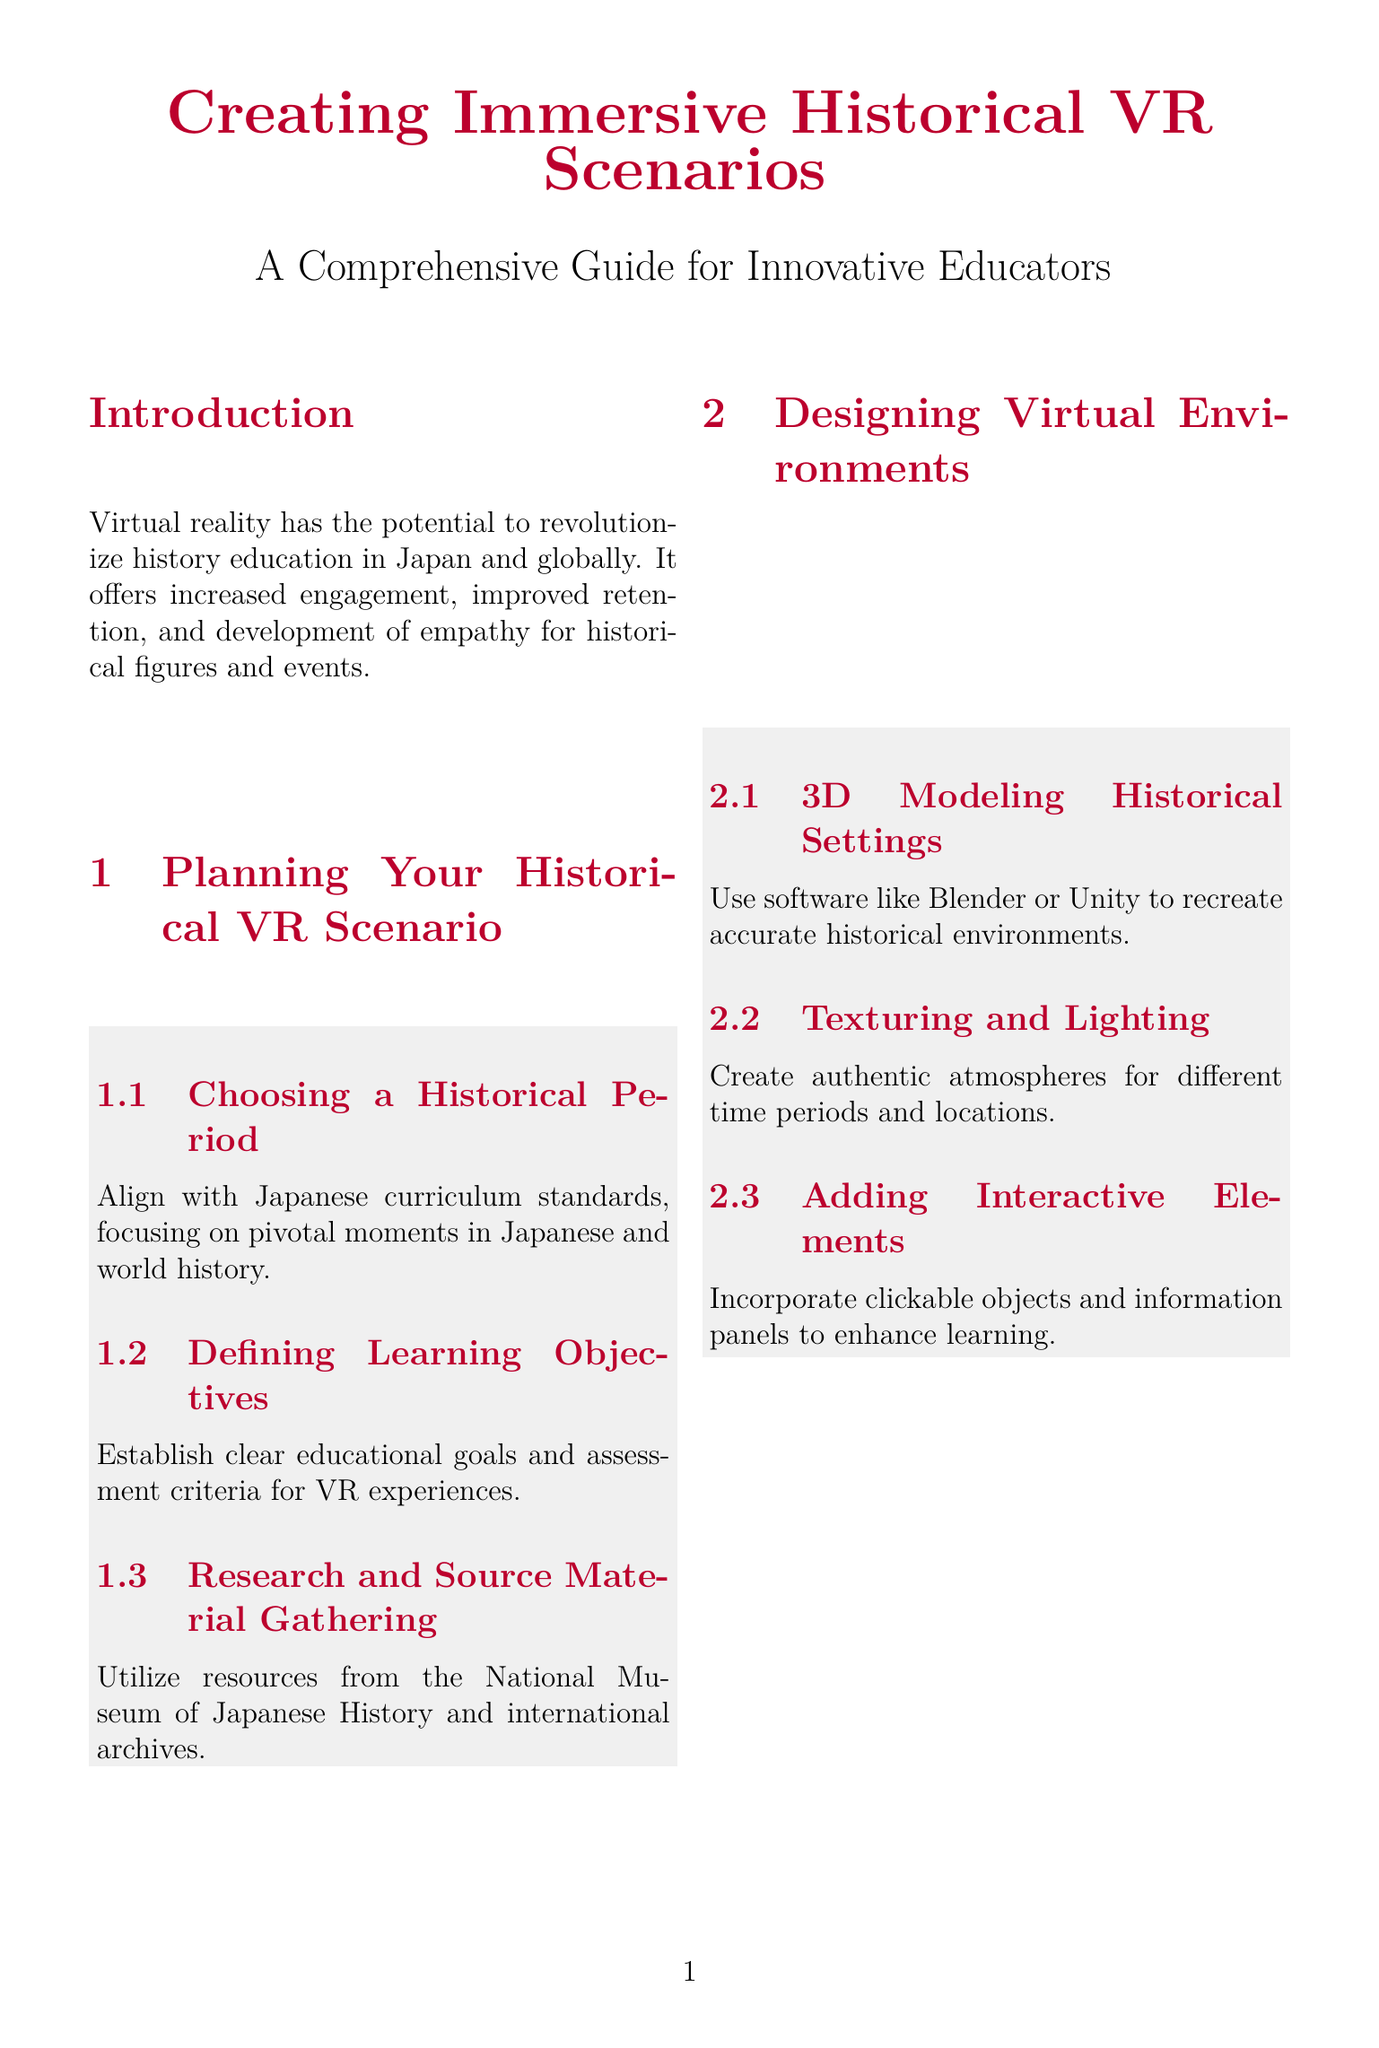what is the title of the manual? The title is usually found at the heading of the document, providing the overall subject matter.
Answer: Creating Immersive Historical VR Scenarios: A Comprehensive Guide for Innovative Educators what is the first section of Chapter 1? Chapter titles often outline key themes or topics, and the first section is usually mentioned under the main chapter title.
Answer: Choosing a Historical Period which software is recommended for 3D modeling? The document lists specific software tools recommended for a task, and this is found under the section about 3D modeling.
Answer: Blender or Unity how many case studies are included? The number of case studies is typically listed in the document, providing examples relevant to the content.
Answer: Three what is one benefit of VR in history education mentioned? The benefits of VR education are usually highlighted in the introduction, summarizing its advantages.
Answer: Increased engagement what type of activities should be included in lesson plan development? Lesson plan objectives are often stated explicitly in relation to the subject matter.
Answer: VR experiences which historical period is focused on in the case study about Hiroshima? Each case study usually specifies the historical event or period being studied, providing context.
Answer: 1945 what is the main focus of Chapter 4? Chapter titles summarize the primary focus or activities that are addressed, typically giving insight into what the chapter will cover.
Answer: Developing Interactive Narratives what is the purpose of the appendices? Appendices are usually added to support the main content with additional information or resources.
Answer: Provide additional resources 